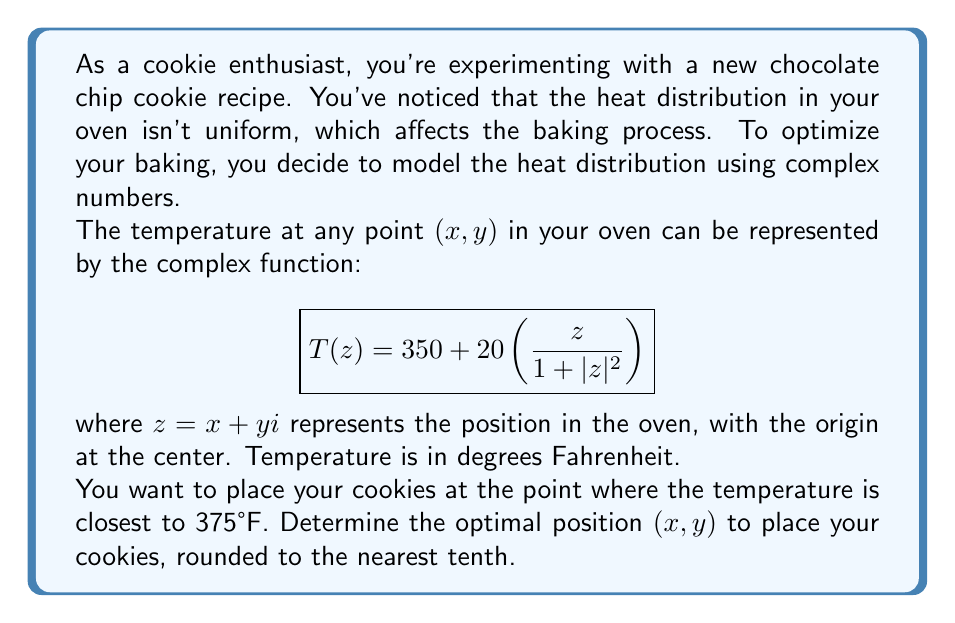Solve this math problem. Let's approach this step-by-step:

1) We need to find the point $z = x + yi$ where $|T(z) - 375|$ is minimized.

2) Expanding the given function:
   $$T(z) = 350 + 20\left(\frac{x+yi}{1+x^2+y^2}\right)$$

3) The real part of this function represents the actual temperature:
   $$\text{Re}(T(z)) = 350 + 20\left(\frac{x}{1+x^2+y^2}\right)$$

4) We want this to equal 375, so:
   $$375 = 350 + 20\left(\frac{x}{1+x^2+y^2}\right)$$

5) Solving for $x$:
   $$25 = 20\left(\frac{x}{1+x^2+y^2}\right)$$
   $$1.25(1+x^2+y^2) = x$$
   $$1.25 + 1.25x^2 + 1.25y^2 = x$$

6) For this to be true, $y$ must be 0 (otherwise, the left side would always be larger than $x$).

7) With $y=0$, we have:
   $$1.25 + 1.25x^2 = x$$
   $$1.25x^2 - x + 1.25 = 0$$

8) This is a quadratic equation. Solving it:
   $$x = \frac{1 \pm \sqrt{1 - 4(1.25)(1.25)}}{2(1.25)} = \frac{1 \pm \sqrt{-5.25}}{2.5}$$

9) The positive solution is:
   $$x = \frac{1 + \sqrt{5.25}}{2.5} \approx 0.7175$$

Therefore, the optimal position is approximately $(0.7, 0)$ in the oven coordinate system.
Answer: The optimal position to place the cookies is $(0.7, 0.0)$, rounded to the nearest tenth. 